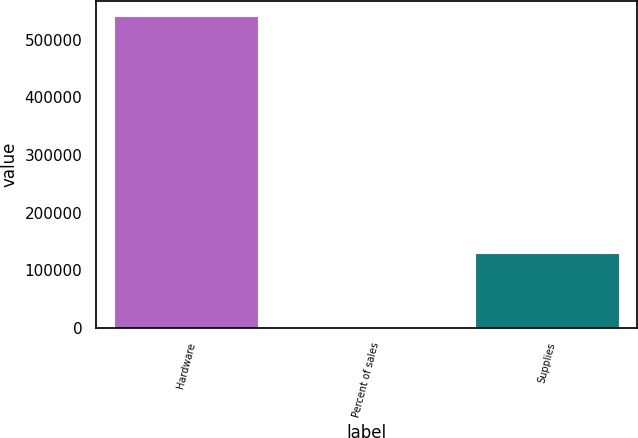<chart> <loc_0><loc_0><loc_500><loc_500><bar_chart><fcel>Hardware<fcel>Percent of sales<fcel>Supplies<nl><fcel>540679<fcel>77<fcel>129183<nl></chart> 